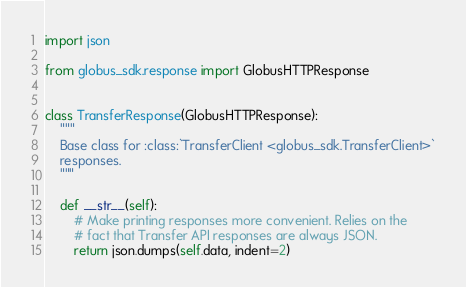<code> <loc_0><loc_0><loc_500><loc_500><_Python_>import json

from globus_sdk.response import GlobusHTTPResponse


class TransferResponse(GlobusHTTPResponse):
    """
    Base class for :class:`TransferClient <globus_sdk.TransferClient>`
    responses.
    """

    def __str__(self):
        # Make printing responses more convenient. Relies on the
        # fact that Transfer API responses are always JSON.
        return json.dumps(self.data, indent=2)
</code> 